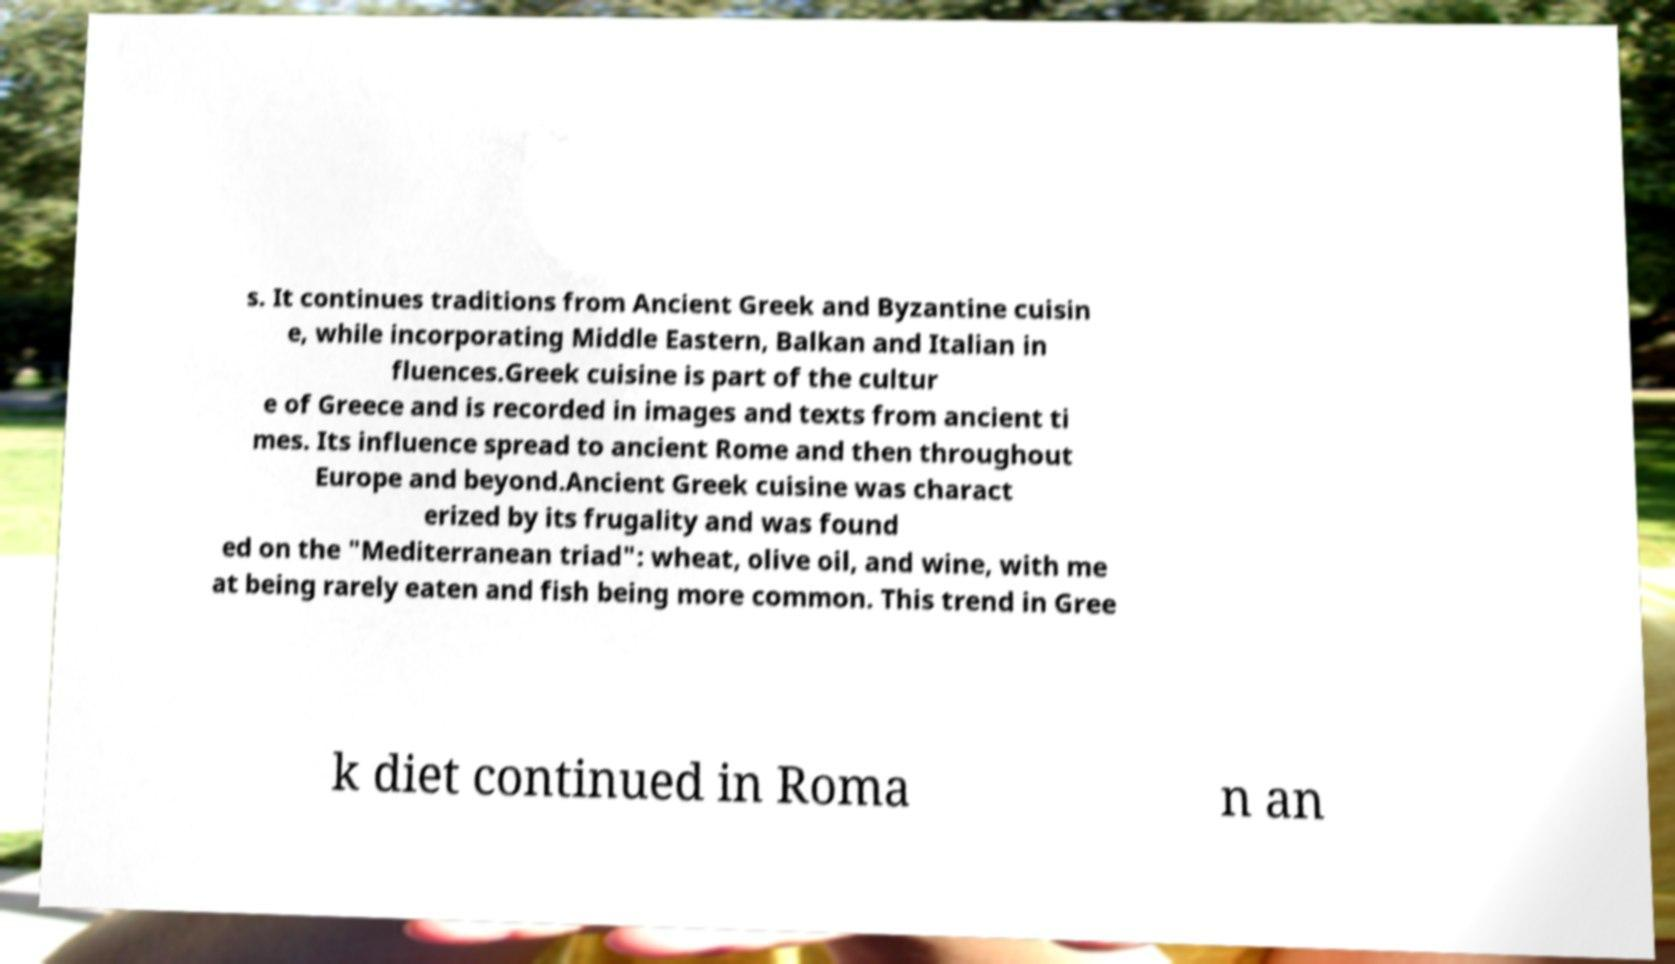I need the written content from this picture converted into text. Can you do that? s. It continues traditions from Ancient Greek and Byzantine cuisin e, while incorporating Middle Eastern, Balkan and Italian in fluences.Greek cuisine is part of the cultur e of Greece and is recorded in images and texts from ancient ti mes. Its influence spread to ancient Rome and then throughout Europe and beyond.Ancient Greek cuisine was charact erized by its frugality and was found ed on the "Mediterranean triad": wheat, olive oil, and wine, with me at being rarely eaten and fish being more common. This trend in Gree k diet continued in Roma n an 